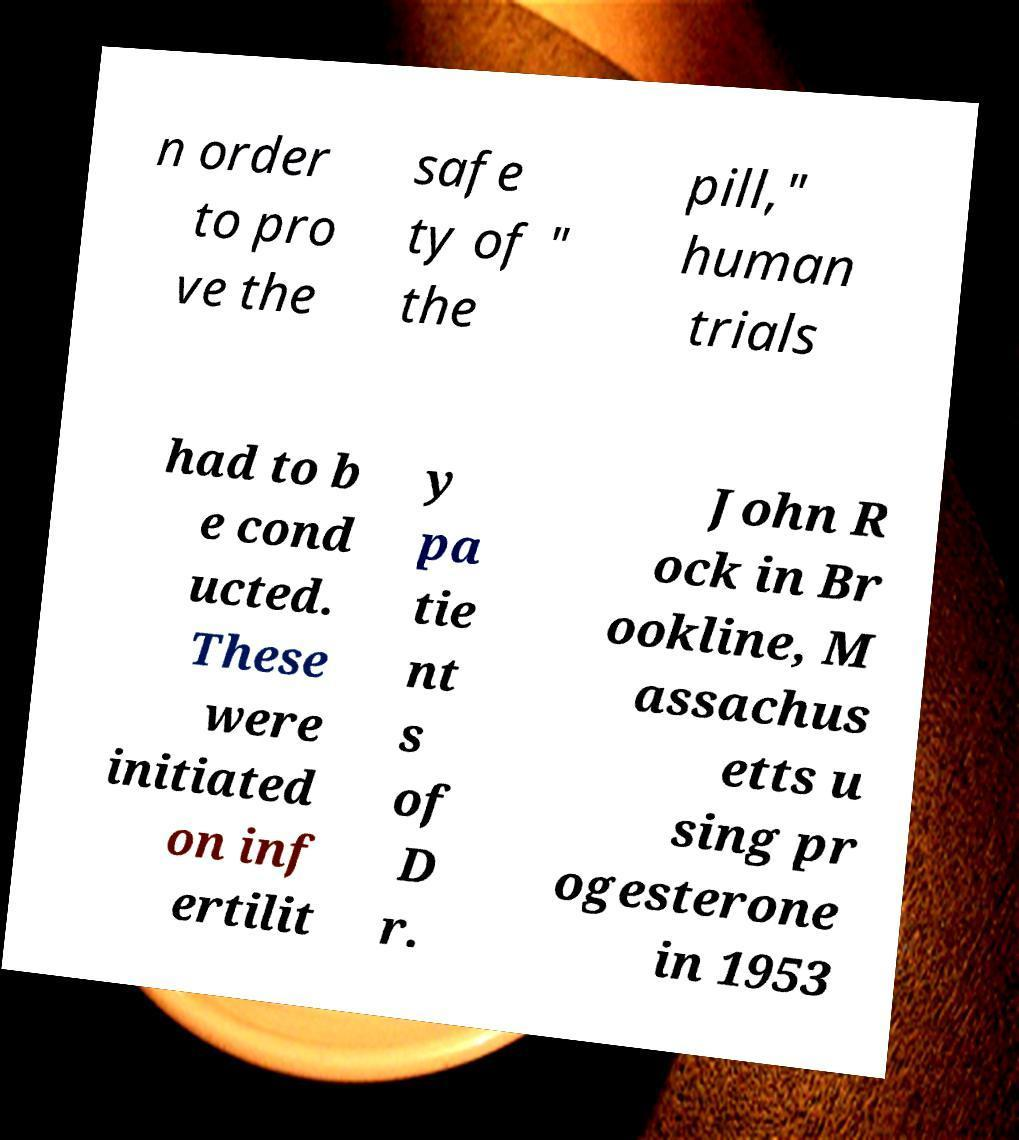Could you assist in decoding the text presented in this image and type it out clearly? n order to pro ve the safe ty of " the pill," human trials had to b e cond ucted. These were initiated on inf ertilit y pa tie nt s of D r. John R ock in Br ookline, M assachus etts u sing pr ogesterone in 1953 